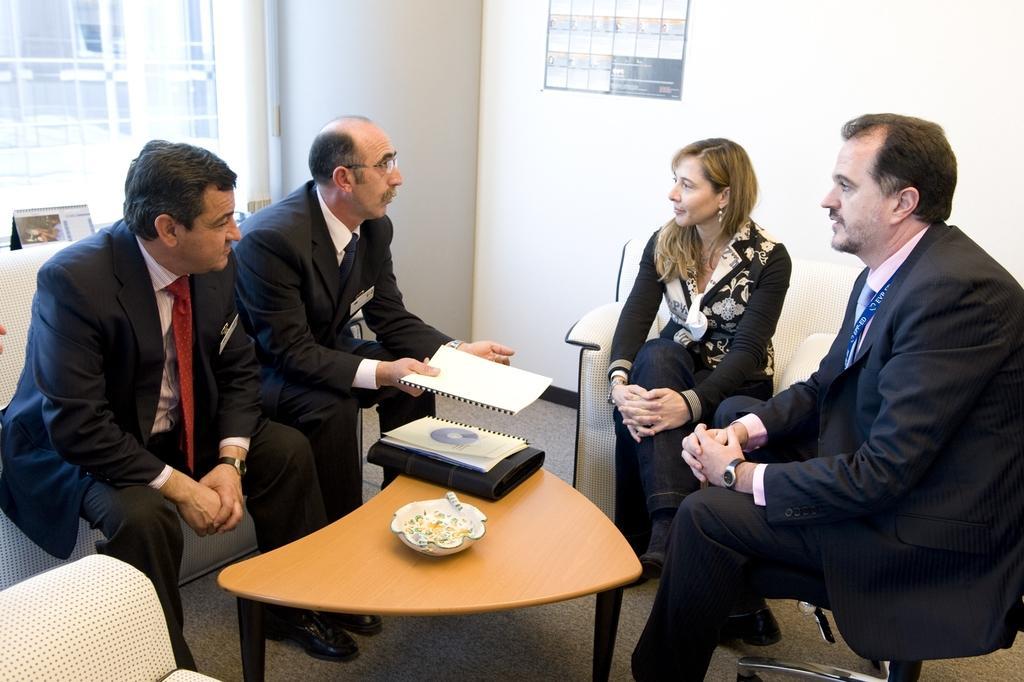Please provide a concise description of this image. In the image there were group of people sitting on a sofa in a room, there were three men and one woman. All the men are in black blazers. In the background there is a door, window and to the left there is a calendar. All the sofas are cream in color. In the center there is a table, a bowl and two files on it. 